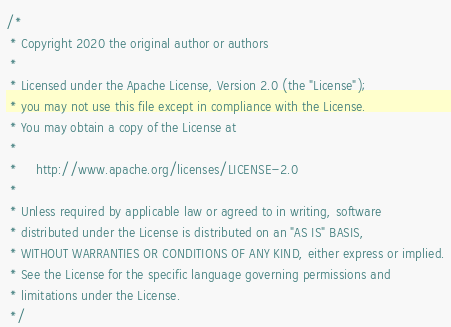Convert code to text. <code><loc_0><loc_0><loc_500><loc_500><_Java_>/*
 * Copyright 2020 the original author or authors
 *
 * Licensed under the Apache License, Version 2.0 (the "License");
 * you may not use this file except in compliance with the License.
 * You may obtain a copy of the License at
 *
 *     http://www.apache.org/licenses/LICENSE-2.0
 *
 * Unless required by applicable law or agreed to in writing, software
 * distributed under the License is distributed on an "AS IS" BASIS,
 * WITHOUT WARRANTIES OR CONDITIONS OF ANY KIND, either express or implied.
 * See the License for the specific language governing permissions and
 * limitations under the License.
 */
</code> 